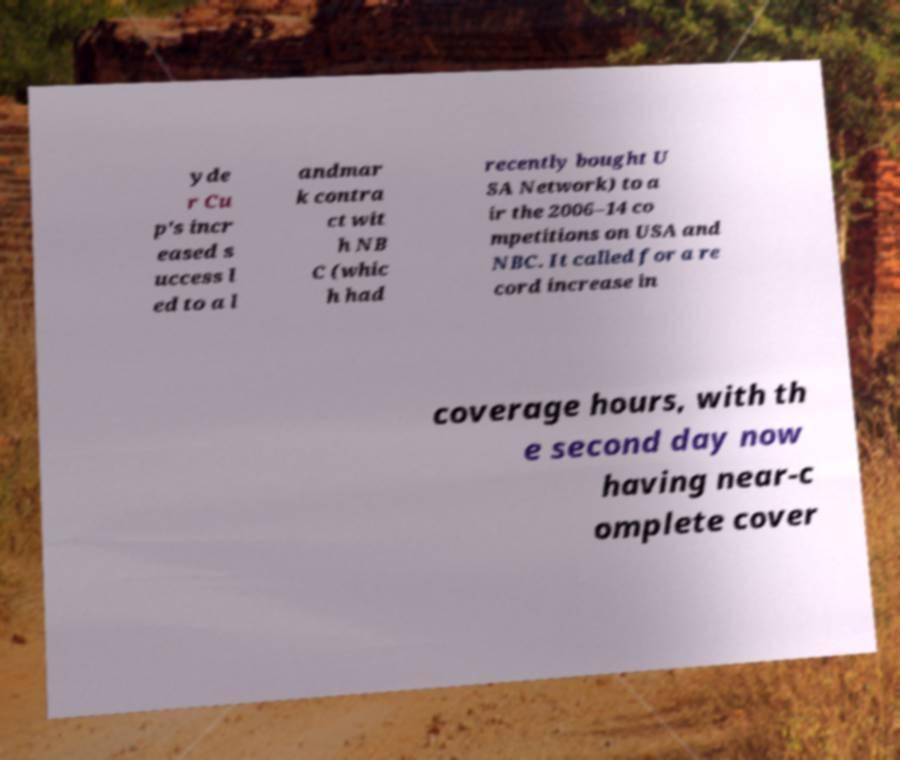Could you extract and type out the text from this image? yde r Cu p's incr eased s uccess l ed to a l andmar k contra ct wit h NB C (whic h had recently bought U SA Network) to a ir the 2006–14 co mpetitions on USA and NBC. It called for a re cord increase in coverage hours, with th e second day now having near-c omplete cover 